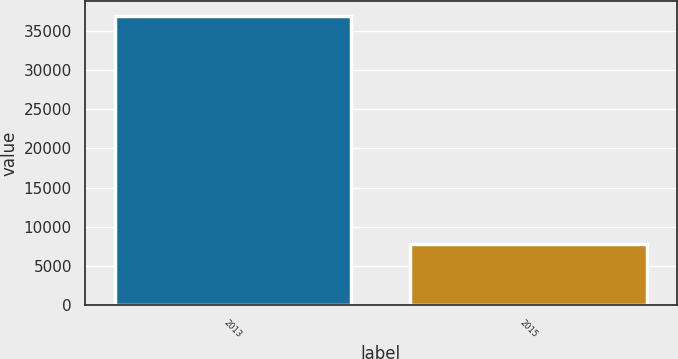<chart> <loc_0><loc_0><loc_500><loc_500><bar_chart><fcel>2013<fcel>2015<nl><fcel>36992<fcel>7750<nl></chart> 